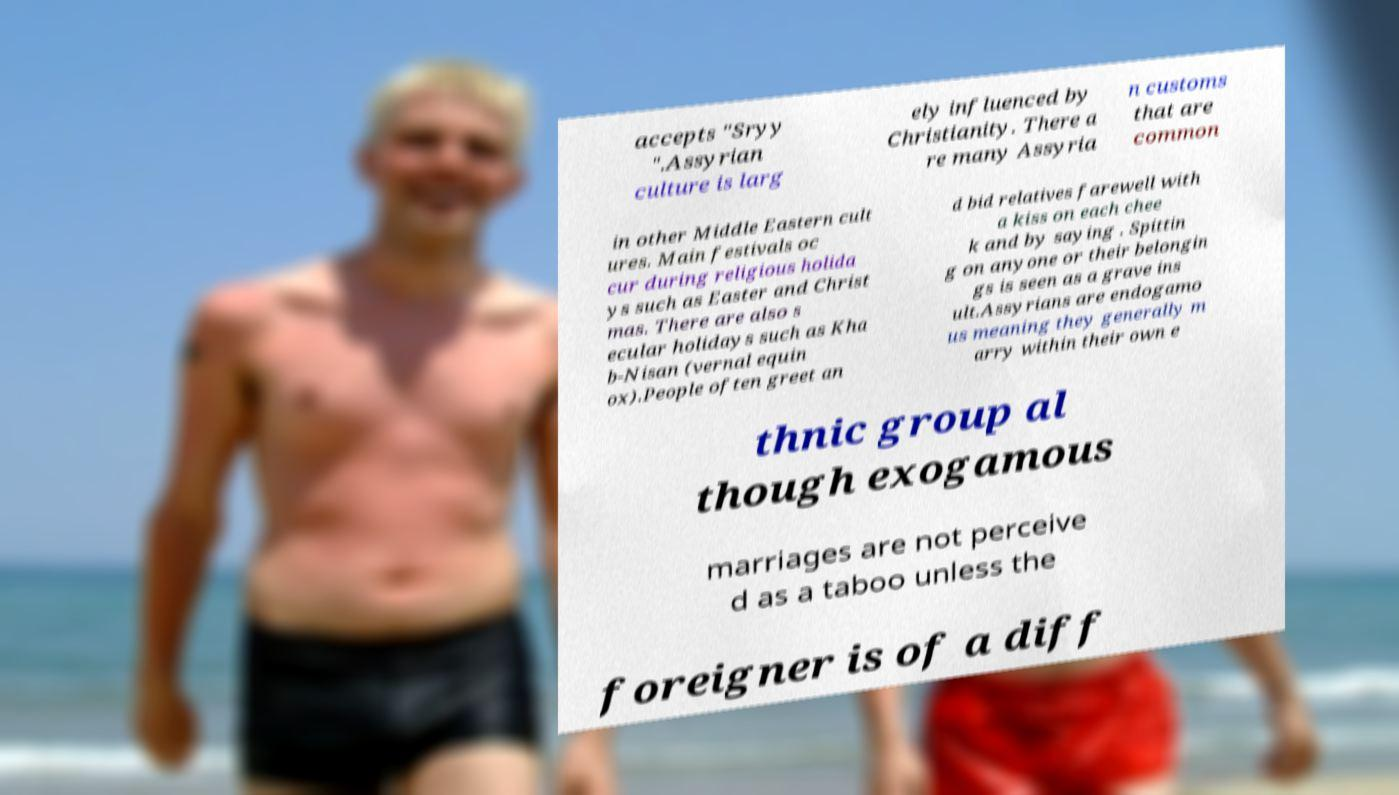There's text embedded in this image that I need extracted. Can you transcribe it verbatim? accepts "Sryy ".Assyrian culture is larg ely influenced by Christianity. There a re many Assyria n customs that are common in other Middle Eastern cult ures. Main festivals oc cur during religious holida ys such as Easter and Christ mas. There are also s ecular holidays such as Kha b-Nisan (vernal equin ox).People often greet an d bid relatives farewell with a kiss on each chee k and by saying . Spittin g on anyone or their belongin gs is seen as a grave ins ult.Assyrians are endogamo us meaning they generally m arry within their own e thnic group al though exogamous marriages are not perceive d as a taboo unless the foreigner is of a diff 